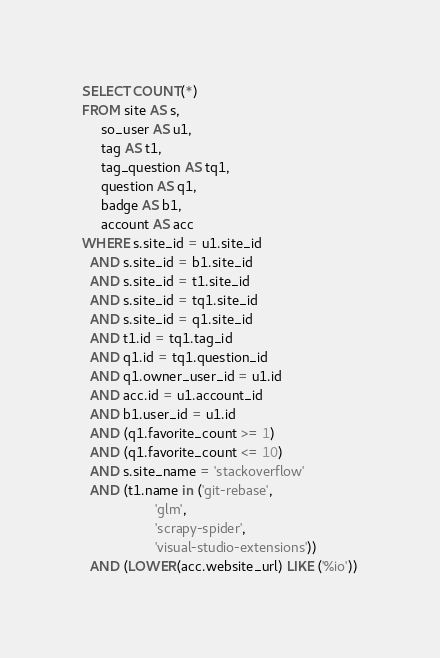<code> <loc_0><loc_0><loc_500><loc_500><_SQL_>SELECT COUNT(*)
FROM site AS s,
     so_user AS u1,
     tag AS t1,
     tag_question AS tq1,
     question AS q1,
     badge AS b1,
     account AS acc
WHERE s.site_id = u1.site_id
  AND s.site_id = b1.site_id
  AND s.site_id = t1.site_id
  AND s.site_id = tq1.site_id
  AND s.site_id = q1.site_id
  AND t1.id = tq1.tag_id
  AND q1.id = tq1.question_id
  AND q1.owner_user_id = u1.id
  AND acc.id = u1.account_id
  AND b1.user_id = u1.id
  AND (q1.favorite_count >= 1)
  AND (q1.favorite_count <= 10)
  AND s.site_name = 'stackoverflow'
  AND (t1.name in ('git-rebase',
                   'glm',
                   'scrapy-spider',
                   'visual-studio-extensions'))
  AND (LOWER(acc.website_url) LIKE ('%io'))</code> 